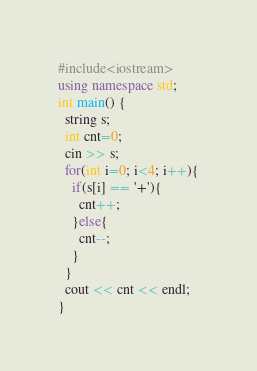Convert code to text. <code><loc_0><loc_0><loc_500><loc_500><_C++_>#include<iostream>
using namespace std;
int main() {
  string s;
  int cnt=0;
  cin >> s;
  for(int i=0; i<4; i++){
    if(s[i] == '+'){
      cnt++;
    }else{
      cnt--;
    }
  }
  cout << cnt << endl;
}</code> 